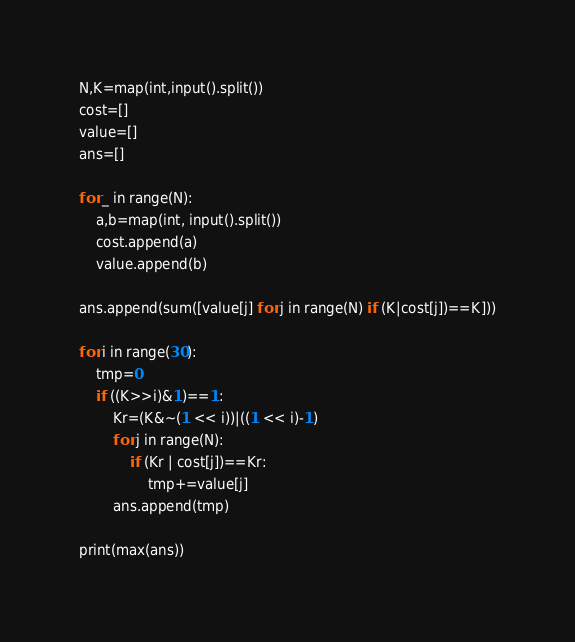Convert code to text. <code><loc_0><loc_0><loc_500><loc_500><_Python_>N,K=map(int,input().split())
cost=[]
value=[]
ans=[]

for _ in range(N):
    a,b=map(int, input().split())
    cost.append(a)
    value.append(b)

ans.append(sum([value[j] for j in range(N) if (K|cost[j])==K]))

for i in range(30):
    tmp=0
    if ((K>>i)&1)==1:
        Kr=(K&~(1 << i))|((1 << i)-1)
        for j in range(N):
            if (Kr | cost[j])==Kr:
                tmp+=value[j]
        ans.append(tmp)

print(max(ans))</code> 